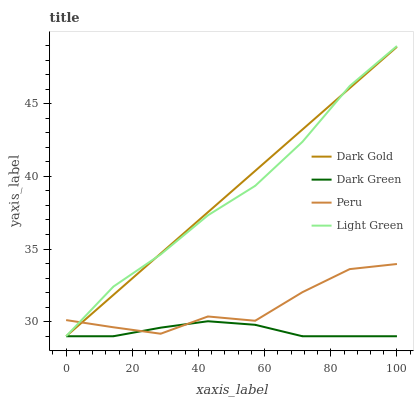Does Dark Green have the minimum area under the curve?
Answer yes or no. Yes. Does Dark Gold have the maximum area under the curve?
Answer yes or no. Yes. Does Light Green have the minimum area under the curve?
Answer yes or no. No. Does Light Green have the maximum area under the curve?
Answer yes or no. No. Is Dark Gold the smoothest?
Answer yes or no. Yes. Is Peru the roughest?
Answer yes or no. Yes. Is Light Green the smoothest?
Answer yes or no. No. Is Light Green the roughest?
Answer yes or no. No. Does Dark Green have the lowest value?
Answer yes or no. Yes. Does Peru have the lowest value?
Answer yes or no. No. Does Light Green have the highest value?
Answer yes or no. Yes. Does Peru have the highest value?
Answer yes or no. No. Does Dark Gold intersect Dark Green?
Answer yes or no. Yes. Is Dark Gold less than Dark Green?
Answer yes or no. No. Is Dark Gold greater than Dark Green?
Answer yes or no. No. 